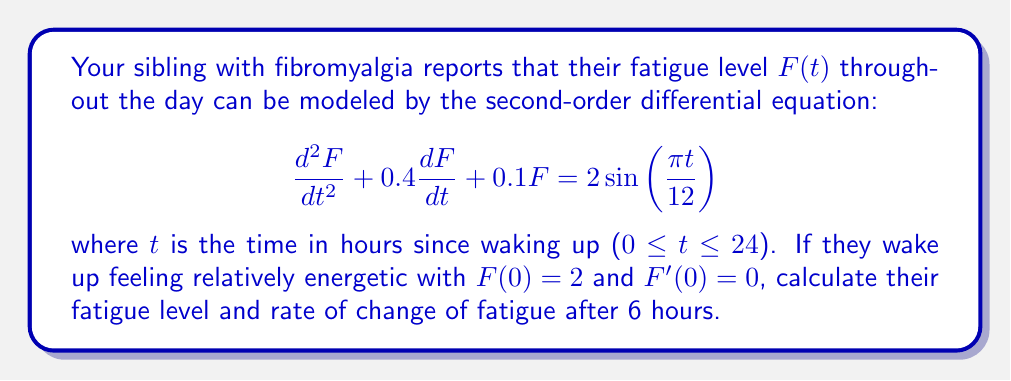Show me your answer to this math problem. To solve this problem, we need to find the general solution to the differential equation and then apply the initial conditions.

1) The general solution to this equation is the sum of the complementary function and the particular integral:

   $F(t) = F_c(t) + F_p(t)$

2) For the complementary function, we solve the characteristic equation:
   $r^2 + 0.4r + 0.1 = 0$
   
   The roots are $r_1 = -0.2 + 0.2i$ and $r_2 = -0.2 - 0.2i$

   So, $F_c(t) = e^{-0.2t}(A\cos(0.2t) + B\sin(0.2t))$

3) For the particular integral, we assume a solution of the form:
   $F_p(t) = C\sin(\frac{\pi t}{12}) + D\cos(\frac{\pi t}{12})$

   Substituting this into the original equation and comparing coefficients, we get:
   $C = 1.9231$ and $D = 0.3077$

4) Therefore, the general solution is:
   $F(t) = e^{-0.2t}(A\cos(0.2t) + B\sin(0.2t)) + 1.9231\sin(\frac{\pi t}{12}) + 0.3077\cos(\frac{\pi t}{12})$

5) Applying the initial conditions:
   $F(0) = 2$ gives: $A + 0.3077 = 2$, so $A = 1.6923$
   $F'(0) = 0$ gives: $-0.2A + 0.2B + 0.5026 = 0$, so $B = 0.8462$

6) The final solution is:
   $F(t) = e^{-0.2t}(1.6923\cos(0.2t) + 0.8462\sin(0.2t)) + 1.9231\sin(\frac{\pi t}{12}) + 0.3077\cos(\frac{\pi t}{12})$

7) To find $F(6)$, we substitute $t = 6$ into this equation.
8) To find $F'(6)$, we differentiate the equation and then substitute $t = 6$:

   $F'(t) = e^{-0.2t}(-0.3385\cos(0.2t) - 0.1692\sin(0.2t) + 0.3385\sin(0.2t) - 0.1692\cos(0.2t)) + 0.5026\cos(\frac{\pi t}{12}) - 0.0804\sin(\frac{\pi t}{12})$
Answer: After 6 hours:
Fatigue level: $F(6) = 3.8629$
Rate of change of fatigue: $F'(6) = 0.1925$ 